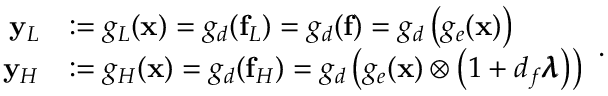<formula> <loc_0><loc_0><loc_500><loc_500>\begin{array} { r l } { y _ { L } } & { \colon = g _ { L } ( x ) = g _ { d } ( f _ { L } ) = g _ { d } ( f ) = g _ { d } \left ( g _ { e } ( x ) \right ) } \\ { y _ { H } } & { \colon = g _ { H } ( x ) = g _ { d } ( f _ { H } ) = g _ { d } \left ( g _ { e } ( x ) \otimes \left ( 1 + d _ { f } \pm b { \lambda } \right ) \right ) } \end{array} .</formula> 